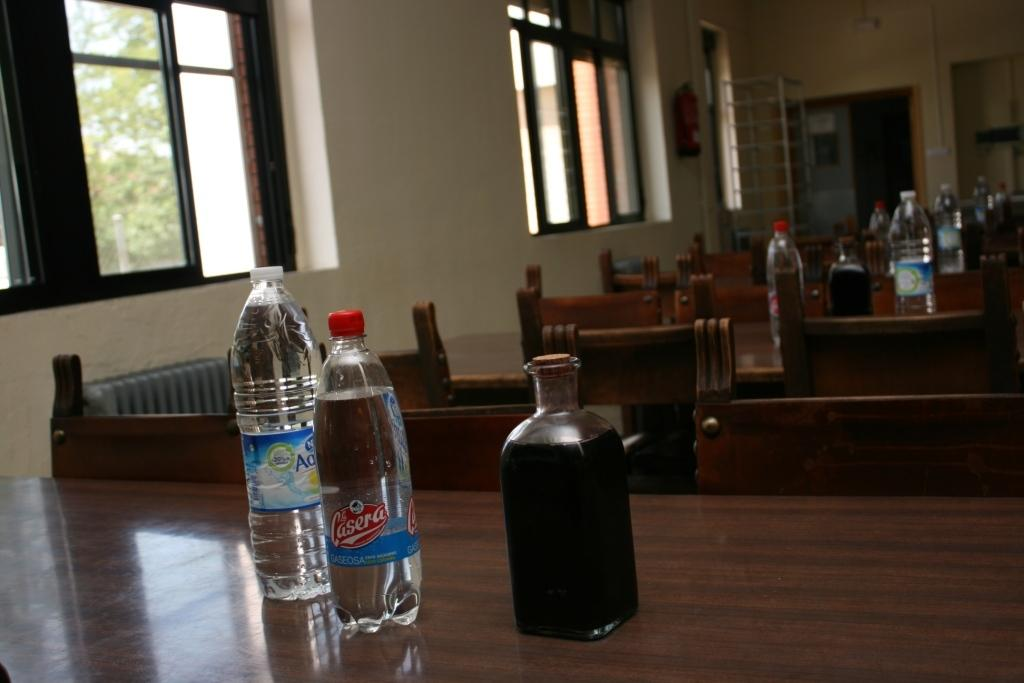Provide a one-sentence caption for the provided image. The drink with the red bottle cap is La Casera. 